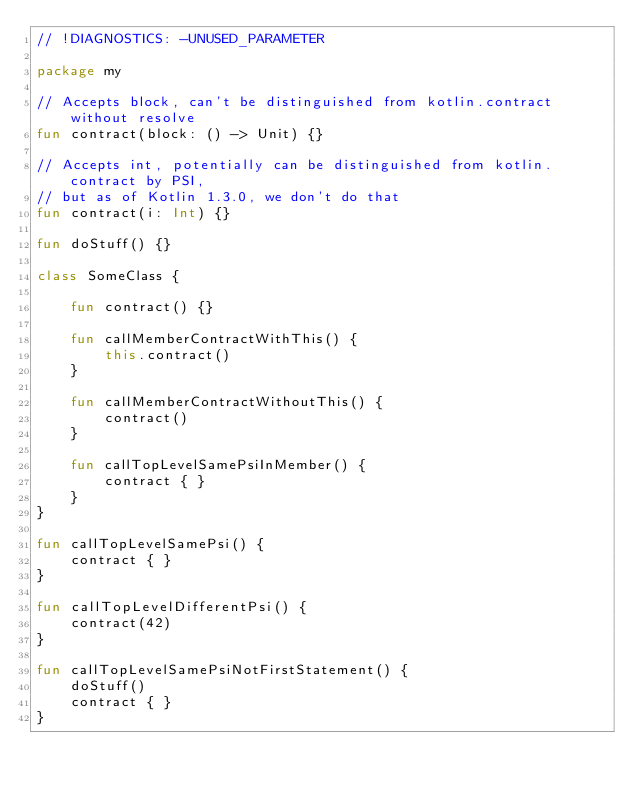<code> <loc_0><loc_0><loc_500><loc_500><_Kotlin_>// !DIAGNOSTICS: -UNUSED_PARAMETER

package my

// Accepts block, can't be distinguished from kotlin.contract without resolve
fun contract(block: () -> Unit) {}

// Accepts int, potentially can be distinguished from kotlin.contract by PSI,
// but as of Kotlin 1.3.0, we don't do that
fun contract(i: Int) {}

fun doStuff() {}

class SomeClass {

    fun contract() {}

    fun callMemberContractWithThis() {
        this.contract()
    }

    fun callMemberContractWithoutThis() {
        contract()
    }

    fun callTopLevelSamePsiInMember() {
        contract { }
    }
}

fun callTopLevelSamePsi() {
    contract { }
}

fun callTopLevelDifferentPsi() {
    contract(42)
}

fun callTopLevelSamePsiNotFirstStatement() {
    doStuff()
    contract { }
}
</code> 